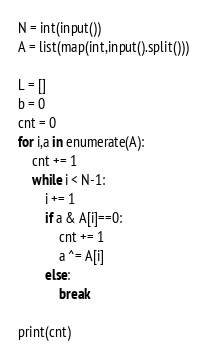Convert code to text. <code><loc_0><loc_0><loc_500><loc_500><_Python_>N = int(input())
A = list(map(int,input().split()))

L = []
b = 0
cnt = 0
for i,a in enumerate(A):
    cnt += 1
    while i < N-1:
        i += 1
        if a & A[i]==0:
            cnt += 1
            a ^= A[i]
        else:
            break

print(cnt)</code> 